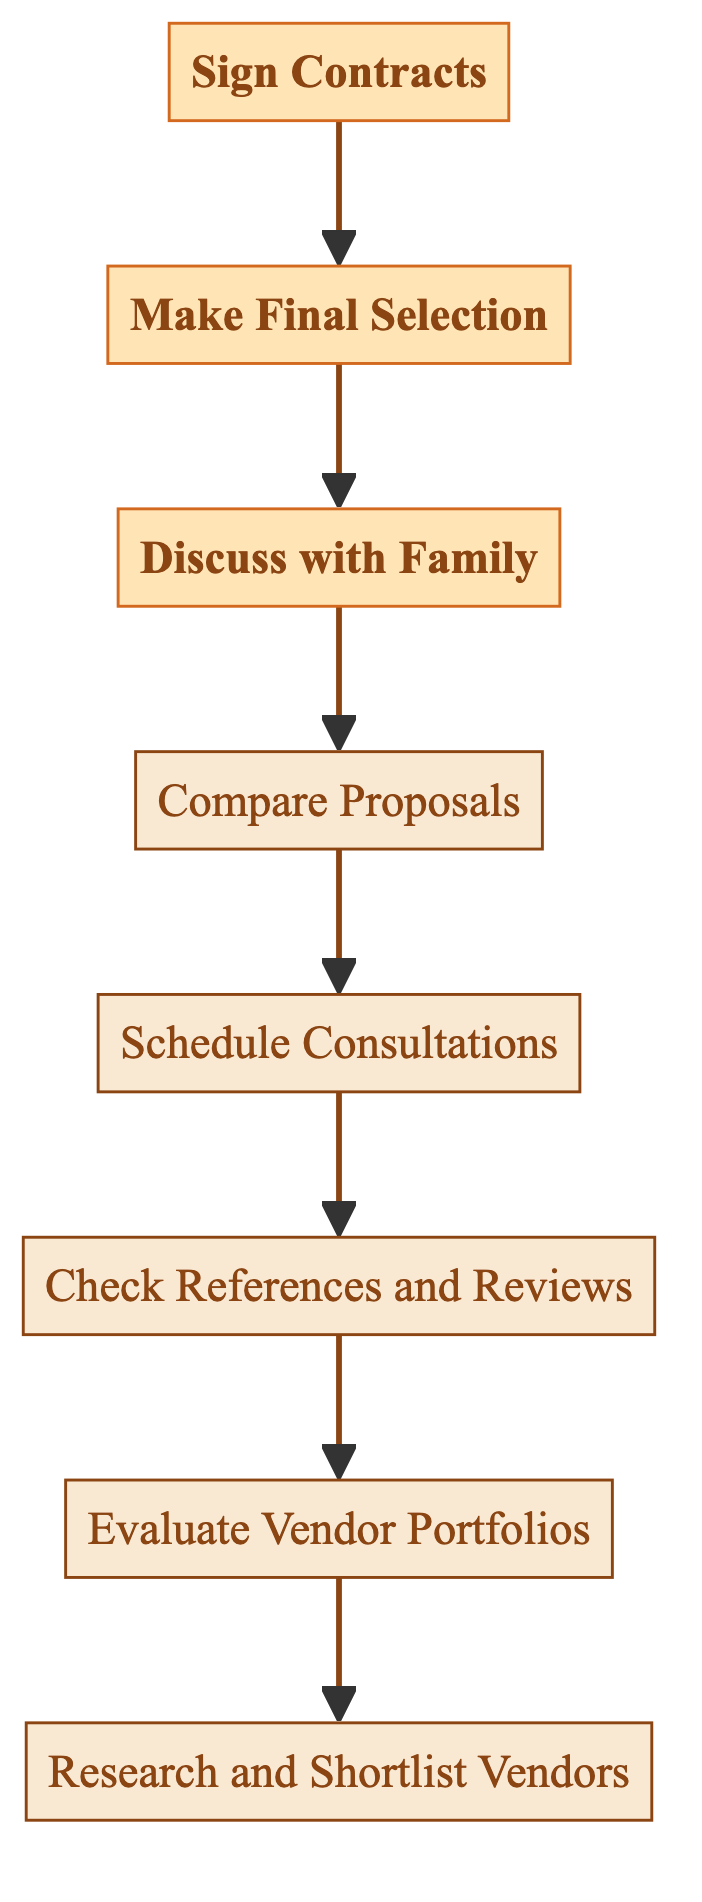What is the first step in the selection process? The flow chart indicates that the first step is “Research and Shortlist Vendors,” which is at the bottom of the diagram.
Answer: Research and Shortlist Vendors How many steps are there in the selection process? By counting from the bottom to the top of the flow chart, there are eight distinct steps outlined, which engage in various vendor selection activities.
Answer: Eight What connects "Sign Contracts" to the preceding step? The flow chart shows an arrow indicating that "Sign Contracts" is directly preceded by "Make Final Selection." This implies that signing contracts occurs after a decision has been made regarding vendor selection.
Answer: Make Final Selection What is the last step in the vendor selection process? The last step at the top of the flow chart is "Sign Contracts," which signifies the final action taken after vendor selection.
Answer: Sign Contracts Which two steps directly follow “Check References and Reviews”? According to the diagram, the step that directly follows “Check References and Reviews” is “Schedule Consultations,” which then leads to “Compare Proposals.”
Answer: Schedule Consultations, Compare Proposals What step involves discussing the proposals with family? The diagram illustrates that the step titled "Discuss with Family" follows after "Compare Proposals," where opinions and preferences regarding vendors are gathered.
Answer: Discuss with Family Which steps do not lead to any further actions after them? The final step, "Sign Contracts," does not lead to any further actions, as it concludes the selection process.
Answer: Sign Contracts What is the relationship between "Evaluate Vendor Portfolios" and "Check References and Reviews"? The flow chart depicts that "Evaluate Vendor Portfolios" directly leads to "Check References and Reviews," indicating that evaluating portfolios comes first and informs the checking of references.
Answer: Evaluate Vendor Portfolios leads to Check References and Reviews How many nodes have the word “Vendor” in them? The steps “Research and Shortlist Vendors,” “Evaluate Vendor Portfolios,” “Check References and Reviews,” and “Make Final Selection” all contain the word “Vendor,” totaling four nodes.
Answer: Four 